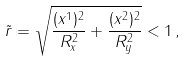<formula> <loc_0><loc_0><loc_500><loc_500>\tilde { r } = \sqrt { \frac { ( x ^ { 1 } ) ^ { 2 } } { R _ { x } ^ { 2 } } + \frac { ( x ^ { 2 } ) ^ { 2 } } { R _ { y } ^ { 2 } } } < 1 \, ,</formula> 